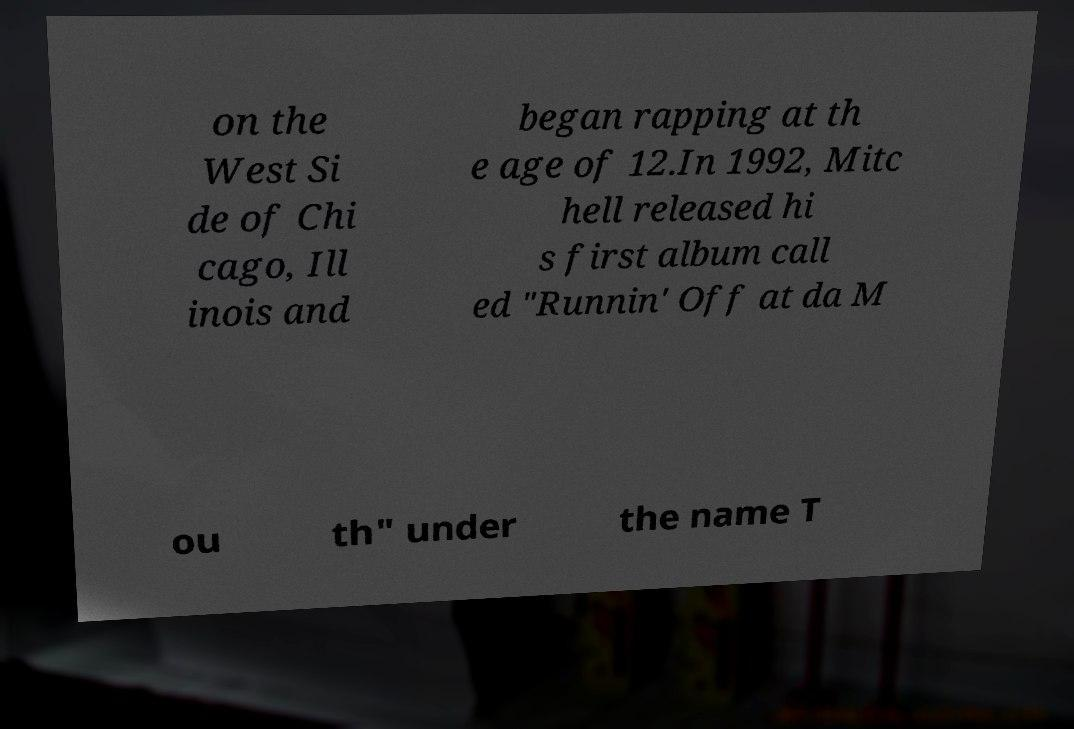Please identify and transcribe the text found in this image. on the West Si de of Chi cago, Ill inois and began rapping at th e age of 12.In 1992, Mitc hell released hi s first album call ed "Runnin' Off at da M ou th" under the name T 